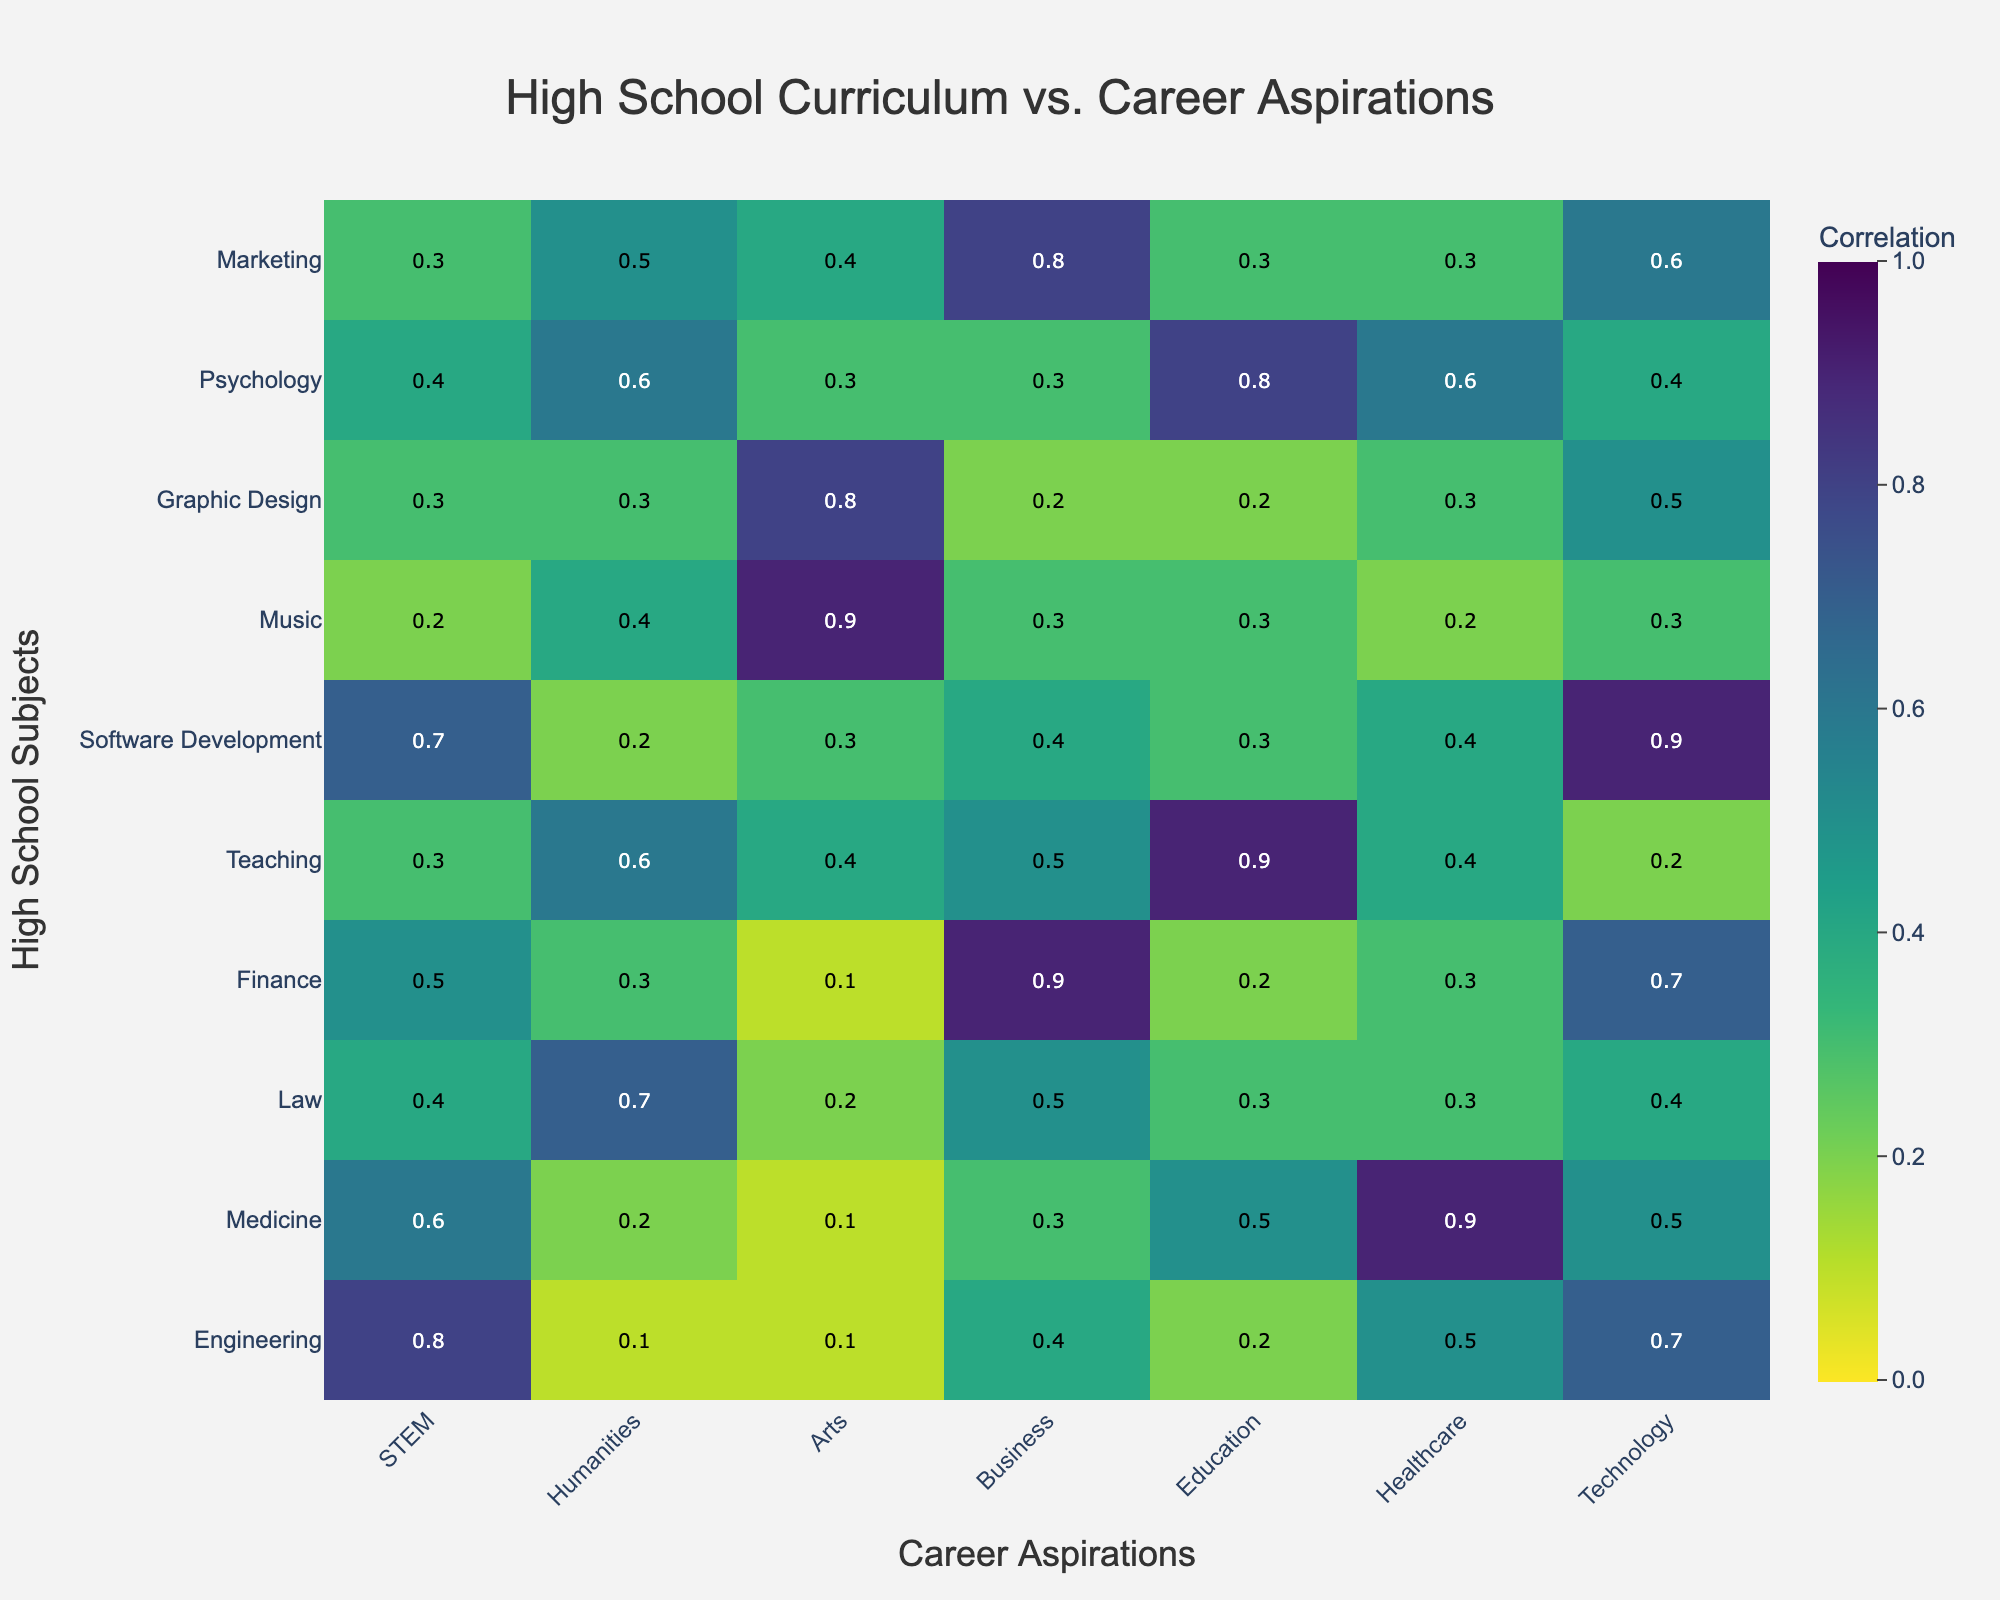What is the highest correlation value in the heatmap, and which subject-career pair does it belong to? To find the highest value, look at the color intensity on the heatmap and confirm by hovering over or checking the annotations. The highest value is 0.9, found in the Medicine-Healthcare pair.
Answer: 0.9 (Medicine-Healthcare) Which subject has the lowest correlation with a career in Business? Locate the Business column and find the lowest number among its values. The lowest correlation value is 0.2 for Graphic Design.
Answer: Graphic Design Which career aspiration shows the most consistent correlation with all subjects? The career that appears to have more uniform (similar) color shades across its column is Healthcare, suggested by the moderate to high correlation values throughout the column. Confirm this by checking the annotations showing values above 0.2 but not having extremes.
Answer: Healthcare Compare the correlation between STEM and Healthcare with Technology and Education. Which is higher? Locate the STEM-Healthcare correlation (0.5) and the Technology-Education correlation (0.2), then compare the values. The STEM-Healthcare correlation is higher.
Answer: STEM-Healthcare For the subject of Graphic Design, what is the average correlation with all the careers listed? Locate the row for Graphic Design and sum the values (0.3 + 0.3 + 0.8 + 0.2 + 0.2 + 0.3 + 0.5). The total is 2.6. There are seven values, so the average is 2.6 / 7 = 0.37.
Answer: 0.37 Which combination shows an equal correlation with a career in Law? First, find the value in the Law column for each subject. The values for Law are: Engineering-0.4, Medicine-0.3, etc. Here, Engineering and Graphic Design both have a correlation of 0.3 with Law.
Answer: Engineering and Graphic Design with Law What is the correlation between the subject of Software Development and the career in Technology, and how does it compare to the correlation between Music and Technology? Locate the correlations for Software Development-Technology (0.9) and Music-Technology (0.3). Compare the two; Software Development has a higher correlation with Technology.
Answer: Software Development-Technology is higher Which subject has the most significant variation in correlation values across all careers? Look for the row with the widest range of values by visually inspecting the heatmap or comparing max and min values per row. The Music subject shows a range from 0.2 to 0.9 (range = 0.7), which is the largest observed.
Answer: Music 